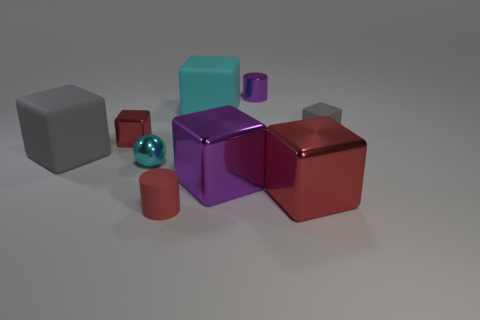What shapes can you identify among the objects? The image contains a range of shapes, including cubes, cylinders, and a sphere. 